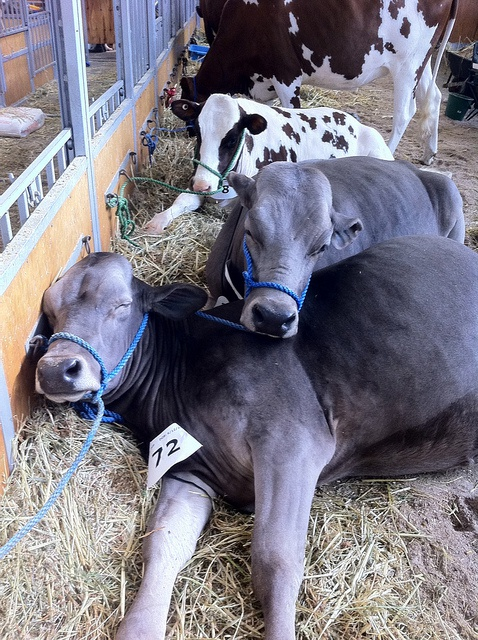Describe the objects in this image and their specific colors. I can see cow in gray, black, and lavender tones, cow in gray and black tones, cow in gray, black, lavender, and darkgray tones, and cow in gray, lavender, black, and darkgray tones in this image. 